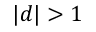Convert formula to latex. <formula><loc_0><loc_0><loc_500><loc_500>| d | > 1</formula> 